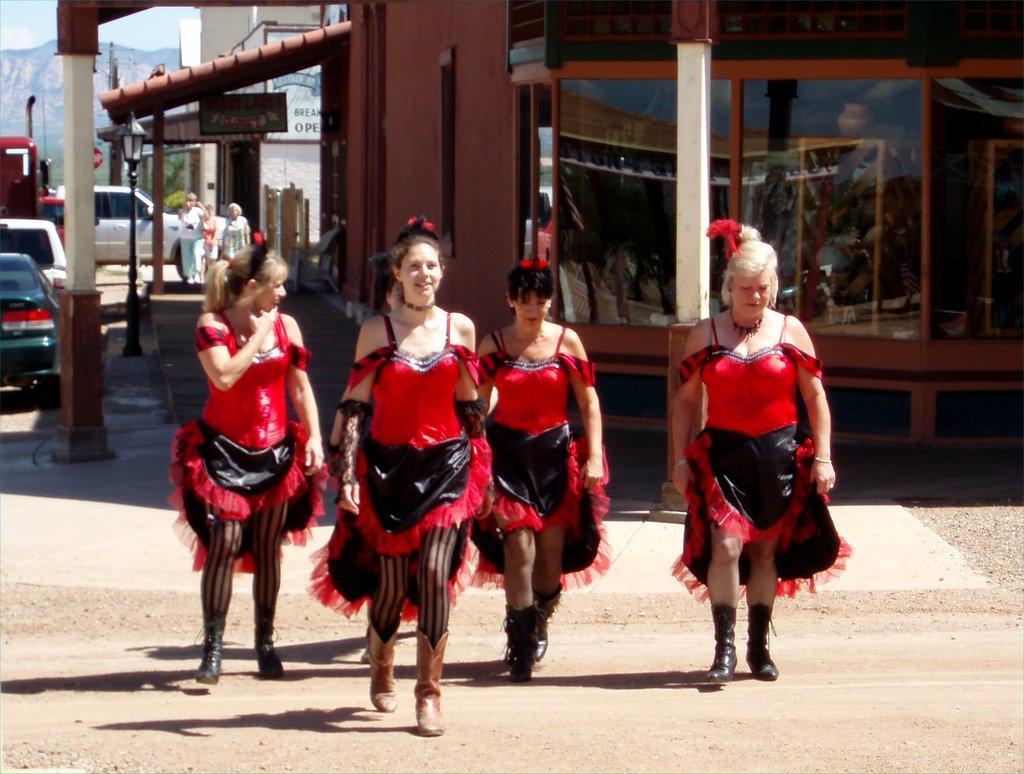Could you give a brief overview of what you see in this image? In the image there are a group of women in the foreground and behind them there are few pillars, windows and on the left side there are few vehicles and there are three people standing in front of one of the vehicle, in the background there is a building and behind the building there are mountains. 